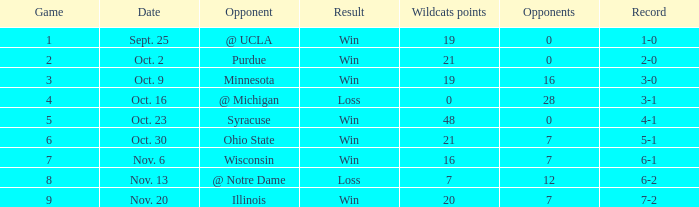What game number did the Wildcats play Purdue? 2.0. 